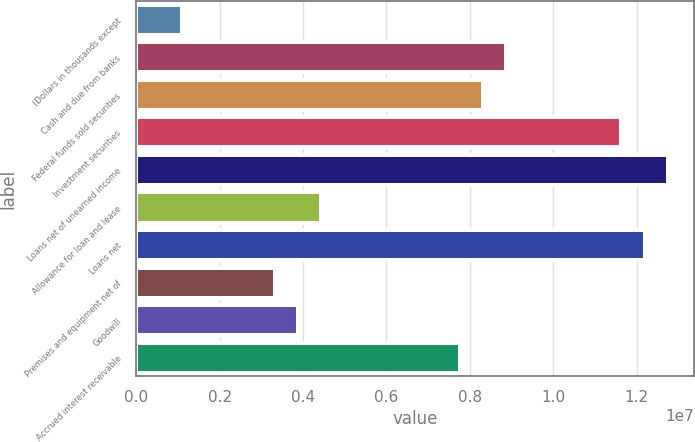<chart> <loc_0><loc_0><loc_500><loc_500><bar_chart><fcel>(Dollars in thousands except<fcel>Cash and due from banks<fcel>Federal funds sold securities<fcel>Investment securities<fcel>Loans net of unearned income<fcel>Allowance for loan and lease<fcel>Loans net<fcel>Premises and equipment net of<fcel>Goodwill<fcel>Accrued interest receivable<nl><fcel>1.10835e+06<fcel>8.86674e+06<fcel>8.31257e+06<fcel>1.16376e+07<fcel>1.27459e+07<fcel>4.43337e+06<fcel>1.21918e+07<fcel>3.32503e+06<fcel>3.8792e+06<fcel>7.7584e+06<nl></chart> 